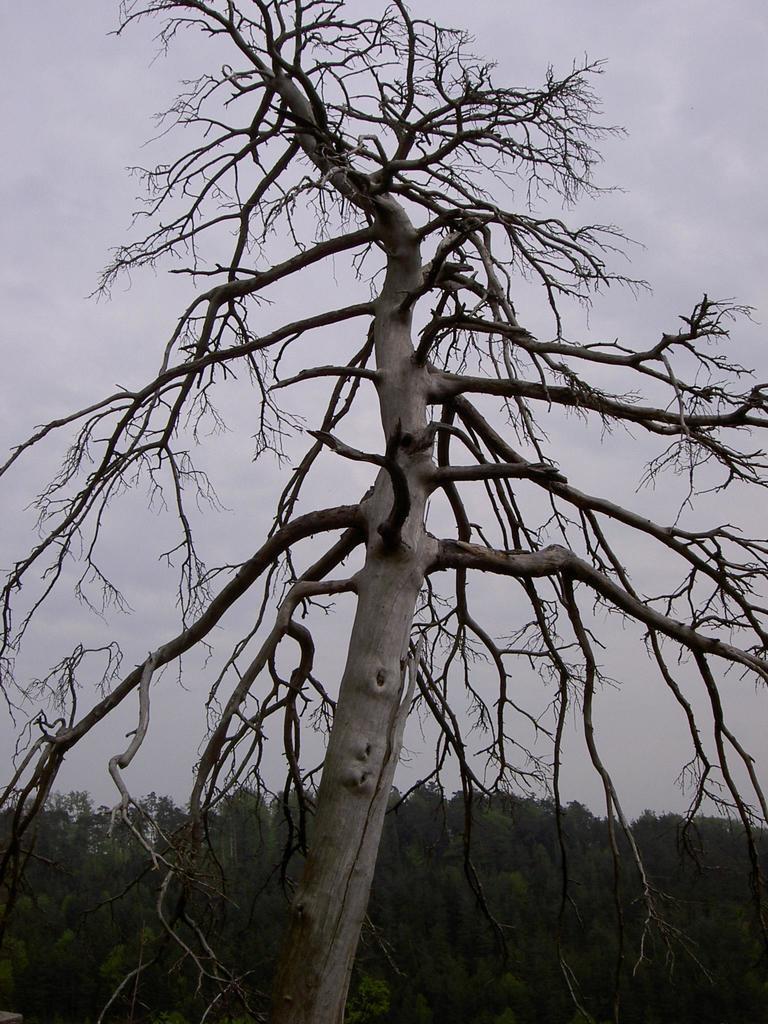How would you summarize this image in a sentence or two? In this image there is a tree in the foreground. There are no leaves to the tree. Behind it there are many trees. At the top there is the sky. 